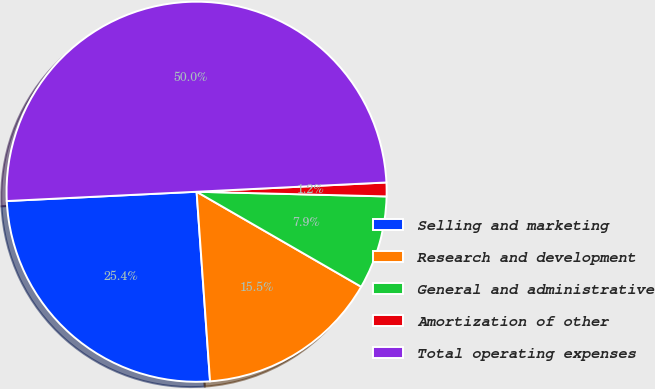Convert chart to OTSL. <chart><loc_0><loc_0><loc_500><loc_500><pie_chart><fcel>Selling and marketing<fcel>Research and development<fcel>General and administrative<fcel>Amortization of other<fcel>Total operating expenses<nl><fcel>25.35%<fcel>15.54%<fcel>7.94%<fcel>1.17%<fcel>50.0%<nl></chart> 